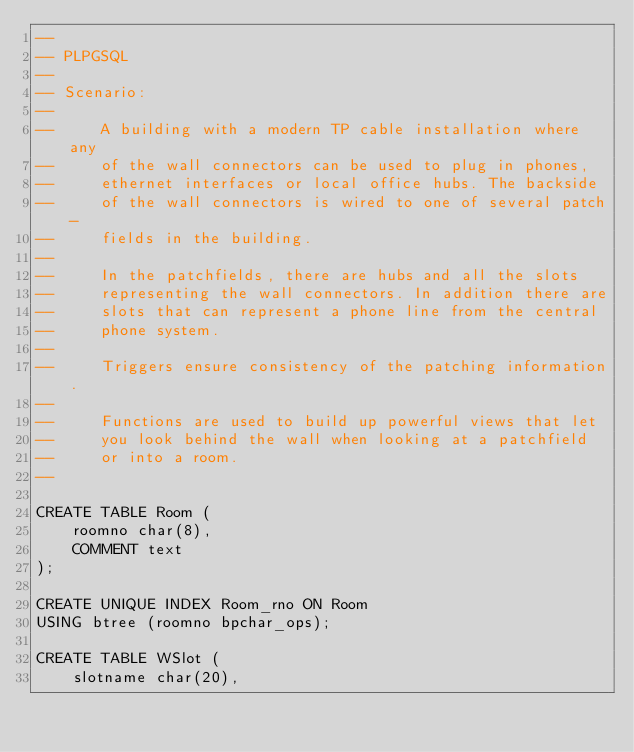<code> <loc_0><loc_0><loc_500><loc_500><_SQL_>--
-- PLPGSQL
--
-- Scenario:
--
--     A building with a modern TP cable installation where any
--     of the wall connectors can be used to plug in phones,
--     ethernet interfaces or local office hubs. The backside
--     of the wall connectors is wired to one of several patch-
--     fields in the building.
--
--     In the patchfields, there are hubs and all the slots
--     representing the wall connectors. In addition there are
--     slots that can represent a phone line from the central
--     phone system.
--
--     Triggers ensure consistency of the patching information.
--
--     Functions are used to build up powerful views that let
--     you look behind the wall when looking at a patchfield
--     or into a room.
--

CREATE TABLE Room (
    roomno char(8),
    COMMENT text
);

CREATE UNIQUE INDEX Room_rno ON Room
USING btree (roomno bpchar_ops);

CREATE TABLE WSlot (
    slotname char(20),</code> 